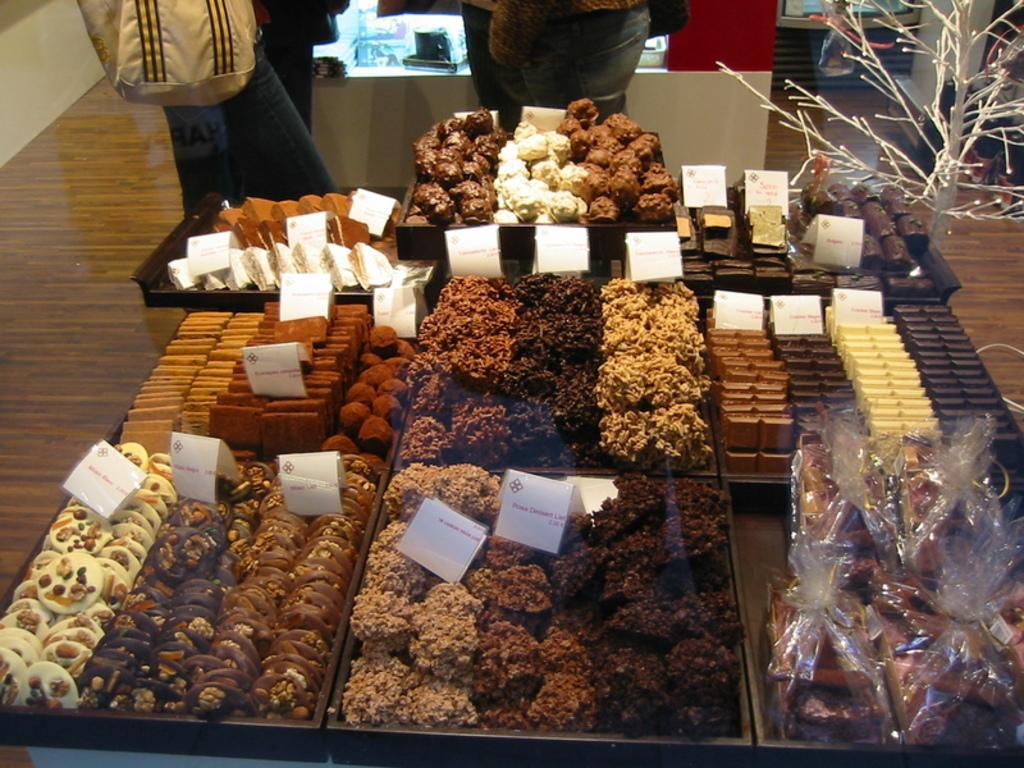In one or two sentences, can you explain what this image depicts? In the image in the center, we can see baskets, banners, chocolates, plastic covers, biscuits and some food items. In the background there is a wall, table, few people are standing and few other objects. 